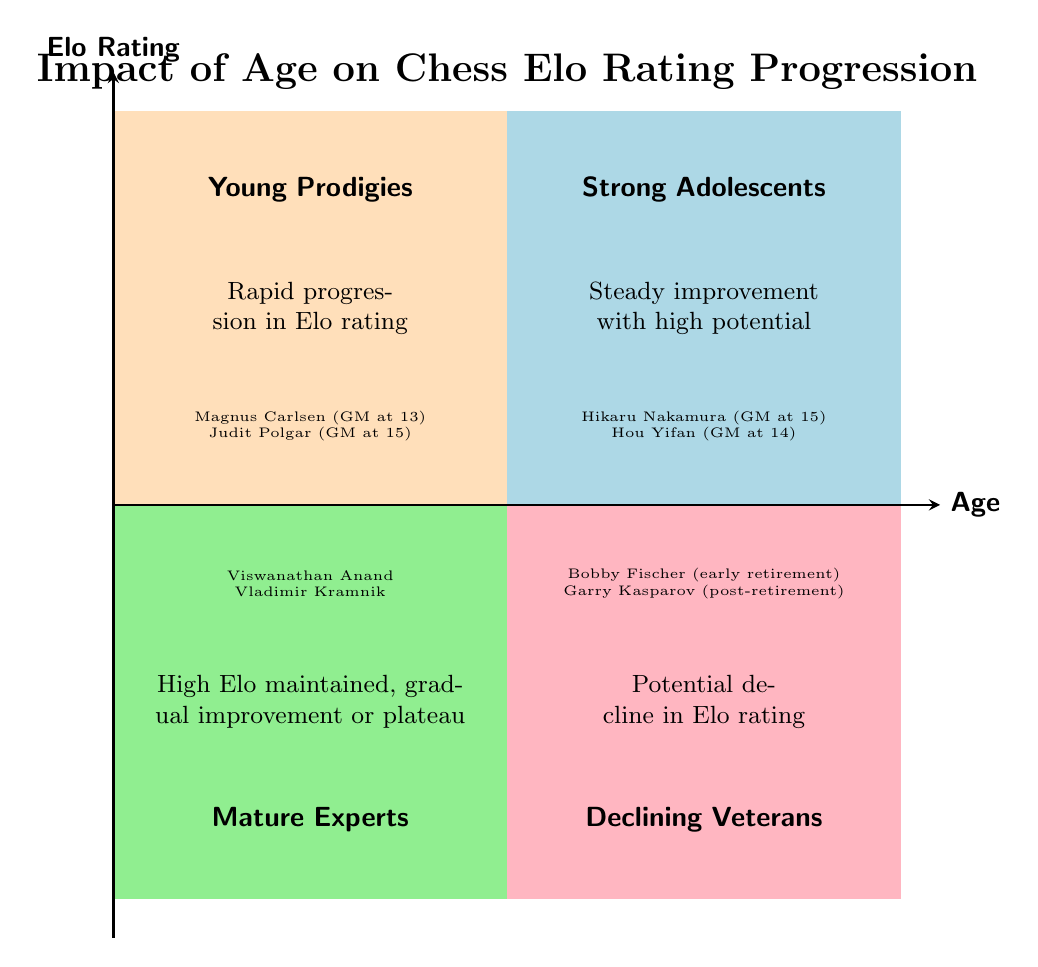What is the title of the diagram? The title of the diagram is clearly indicated at the top, stating "Impact of Age on Chess Elo Rating Progression."
Answer: Impact of Age on Chess Elo Rating Progression Which quadrant represents "Young Prodigies"? The title for the quadrant associated with "Young Prodigies" is placed in the top left section of the diagram, specifically identified as Q1.
Answer: Young Prodigies What is the description of the "Strong Adolescents" quadrant? The description for "Strong Adolescents," located in the top right quadrant (Q2), states "Steady improvement with high potential."
Answer: Steady improvement with high potential How many examples are provided in the "Mature Experts" quadrant? The "Mature Experts" quadrant (Q3) provides two specific examples: Viswanathan Anand and Vladimir Kramnik. Thus, there are two examples listed.
Answer: 2 Which chess player is associated with early retirement in the "Declining Veterans" quadrant? Within the "Declining Veterans" quadrant (Q4), Bobby Fischer is specifically mentioned as an example of a player associated with early retirement.
Answer: Bobby Fischer Explain the difference between the "Young Prodigies" and "Mature Experts" quadrants. The "Young Prodigies" quadrant (Q1) is characterized by rapid progression in Elo rating, showcasing young players like Magnus Carlsen. In contrast, the "Mature Experts" quadrant (Q3) features players who maintain high Elo ratings, with gradual improvement or plateaus, such as Viswanathan Anand.
Answer: Rapid progression vs. high Elo maintenance What color represents "Declining Veterans"? In the quadrant chart, the color associated with "Declining Veterans" (Q4) is a light pink shade, which signifies this category in the visual layout.
Answer: Light pink Which chess player is mentioned as a Grandmaster at the youngest age in the diagram? Among the examples listed, Judit Polgar is identified as a Grandmaster at the age of 15, the youngest age noted in the diagram.
Answer: Judit Polgar 